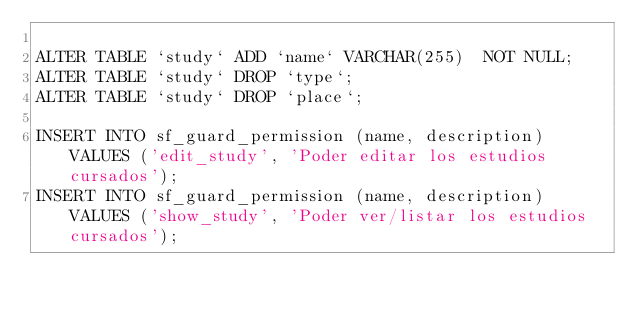Convert code to text. <code><loc_0><loc_0><loc_500><loc_500><_SQL_>
ALTER TABLE `study` ADD `name` VARCHAR(255)  NOT NULL;
ALTER TABLE `study` DROP `type`;
ALTER TABLE `study` DROP `place`;

INSERT INTO sf_guard_permission (name, description) VALUES ('edit_study', 'Poder editar los estudios cursados');
INSERT INTO sf_guard_permission (name, description) VALUES ('show_study', 'Poder ver/listar los estudios cursados');
</code> 